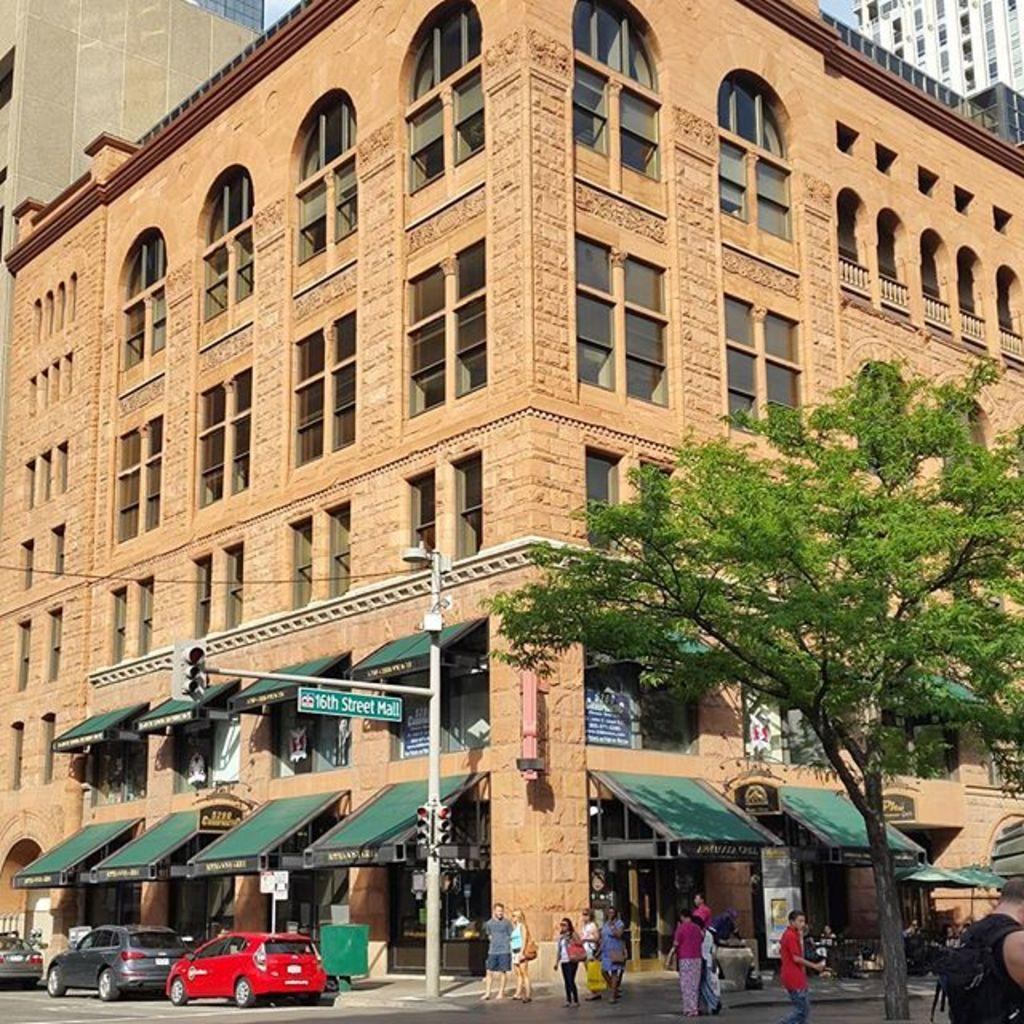What type of structures can be seen in the image? There are buildings in the image. What else can be seen moving in the image? There are vehicles in the image. What are the people in the image doing? There are people on the road in the image. How are the vehicles guided in the image? There are traffic signals in the image. What type of information might be conveyed by the sign board in the image? The sign board in the image might convey information about directions, warnings, or advertisements. What is the source of light attached to the pole in the image? There is a light attached to a pole in the image. What type of barrier can be seen in the image? There is a fence in the image. What type of plant life is visible in the image? There is a tree in the image. How many sheets of paper are being used by the people on the street in the image? There is no mention of paper or sheets in the image; it features buildings, vehicles, people, traffic signals, a sign board, a light, a fence, and a tree. 